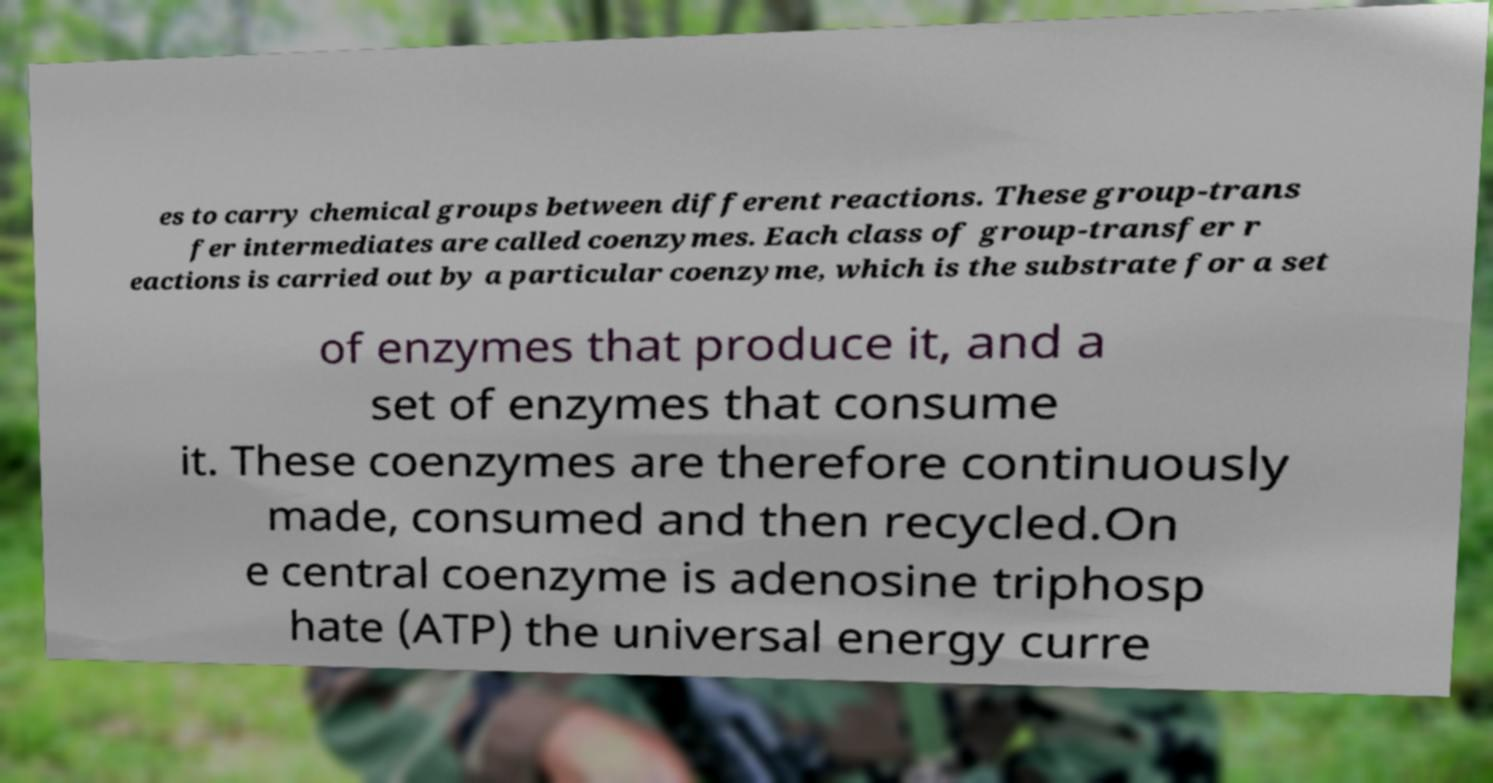I need the written content from this picture converted into text. Can you do that? es to carry chemical groups between different reactions. These group-trans fer intermediates are called coenzymes. Each class of group-transfer r eactions is carried out by a particular coenzyme, which is the substrate for a set of enzymes that produce it, and a set of enzymes that consume it. These coenzymes are therefore continuously made, consumed and then recycled.On e central coenzyme is adenosine triphosp hate (ATP) the universal energy curre 